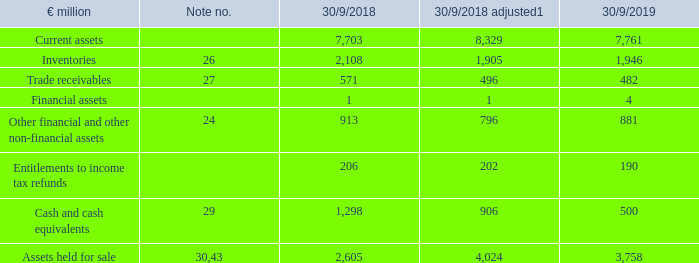Current assets of continuing operations decreased by €569 million compared to the previous year's figures to €7.8 billion (30/9/2018: €8.3 billion). Cash and cash equivalents in particular contributed to this development with a decrease of €407 million to €0.5 billion (30/9/2018: €0.9 billion).
1 Adjusted for effects of the discontinued business segment.
For more information about the development of current assets, see the notes to the consolidated financial statements in the numbers listed in the table.
What was the amount of current assets of continuing operations in FY2019?
Answer scale should be: million. 7,761. What was the amount of cash and cash equivalents in FY2019?
Answer scale should be: million. 500. In which years were the current assets of continuing operations calculated in? 2019, 2018. In which year was the amount of Trade Receivables larger for the FY2018 adjusted figure and FY2019 figures? 496>482
Answer: 2018 adjusted. What was the change in Cash and cash equivalents in FY2019 from FY2018 adjusted?
Answer scale should be: million. 500-906
Answer: -406. What was the percentage change in Cash and cash equivalents in FY2019 from FY2018 adjusted?
Answer scale should be: percent. (500-906)/906
Answer: -44.81. 